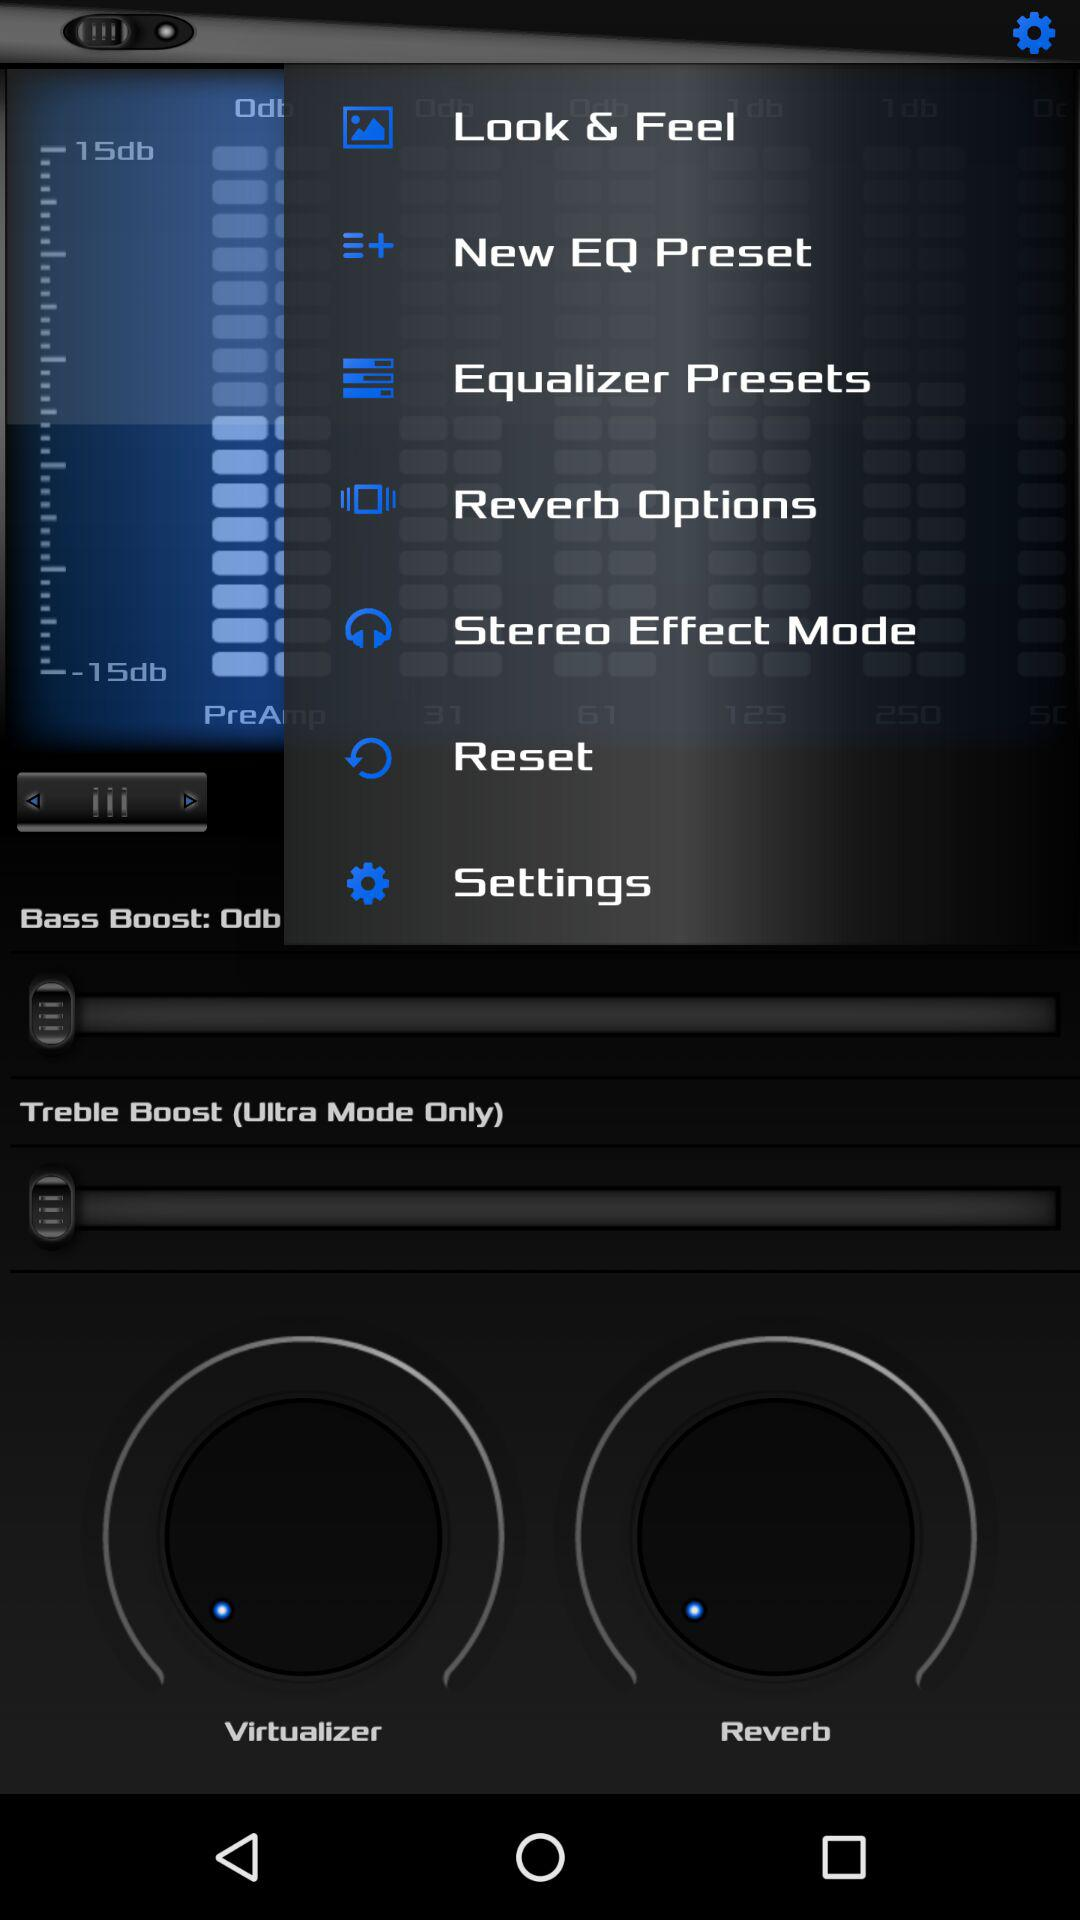What's the treble boost mode? The treble boost mode is ultra. 